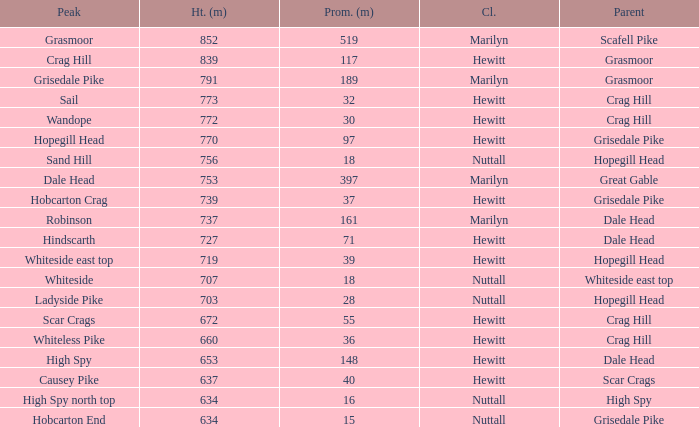Which Parent has height smaller than 756 and a Prom of 39? Hopegill Head. 